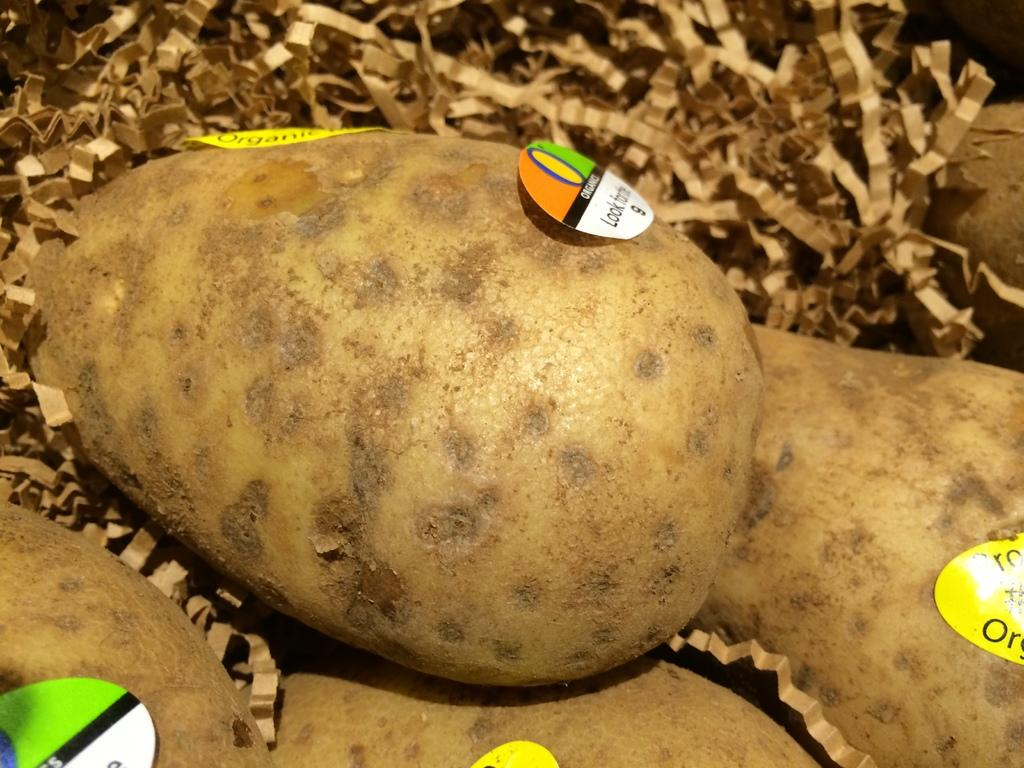What is depicted on the scrap of papers in the image? There are potatoes depicted on the scrap of papers in the image. How many sisters are shown wearing the apparel in the image? There are no sisters or apparel present in the image; it features a scrap of papers with potatoes depicted on it. 